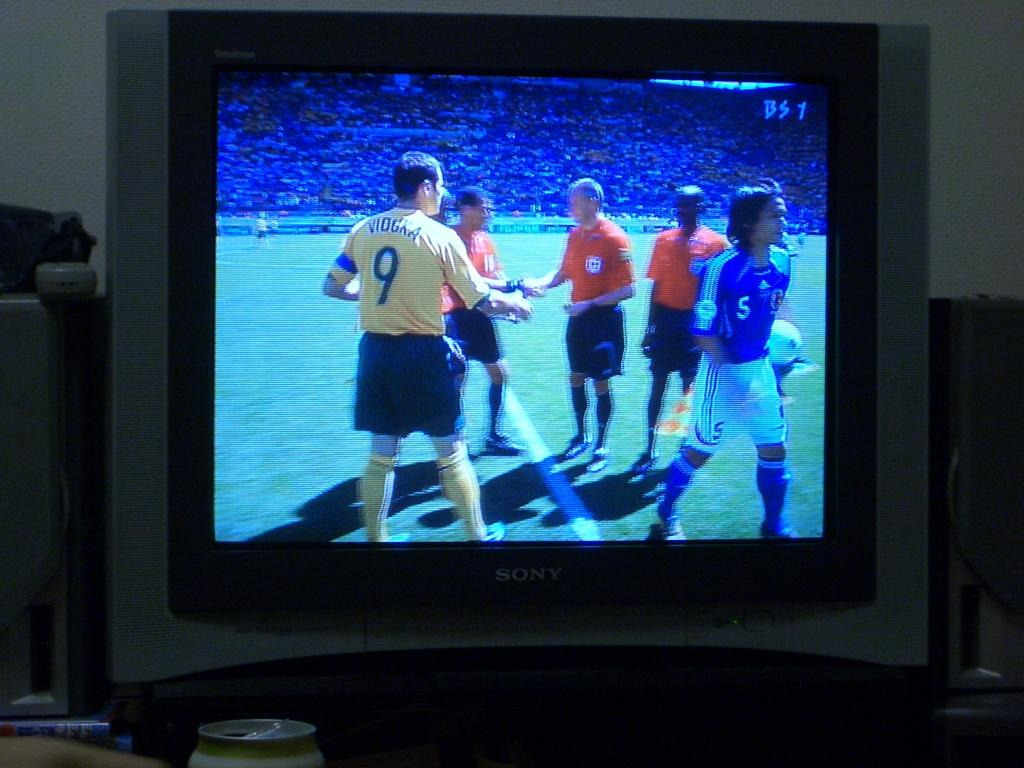<image>
Give a short and clear explanation of the subsequent image. a bs7 name in the top right od the television screen 